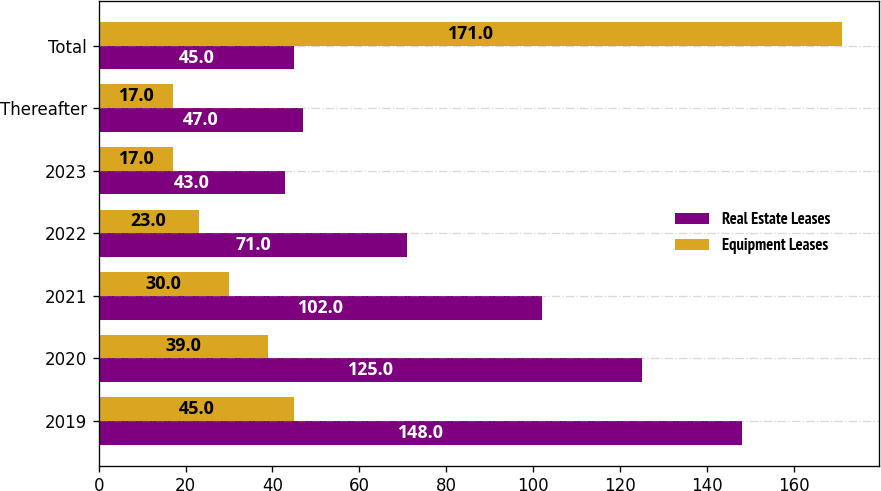<chart> <loc_0><loc_0><loc_500><loc_500><stacked_bar_chart><ecel><fcel>2019<fcel>2020<fcel>2021<fcel>2022<fcel>2023<fcel>Thereafter<fcel>Total<nl><fcel>Real Estate Leases<fcel>148<fcel>125<fcel>102<fcel>71<fcel>43<fcel>47<fcel>45<nl><fcel>Equipment Leases<fcel>45<fcel>39<fcel>30<fcel>23<fcel>17<fcel>17<fcel>171<nl></chart> 